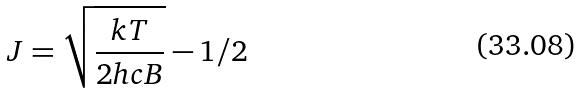Convert formula to latex. <formula><loc_0><loc_0><loc_500><loc_500>J = \sqrt { \frac { k T } { 2 h c B } } - 1 / 2</formula> 